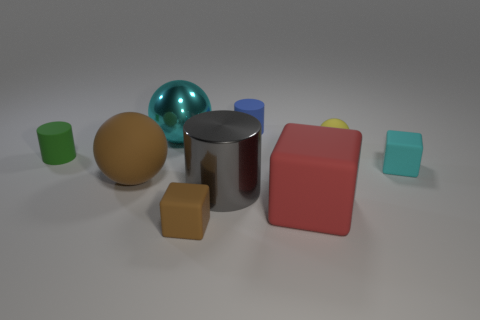Subtract 1 balls. How many balls are left? 2 Add 1 tiny green cylinders. How many objects exist? 10 Subtract all small blocks. How many blocks are left? 1 Subtract all balls. How many objects are left? 6 Subtract all large yellow cylinders. Subtract all yellow balls. How many objects are left? 8 Add 7 large brown balls. How many large brown balls are left? 8 Add 8 tiny rubber spheres. How many tiny rubber spheres exist? 9 Subtract 0 red cylinders. How many objects are left? 9 